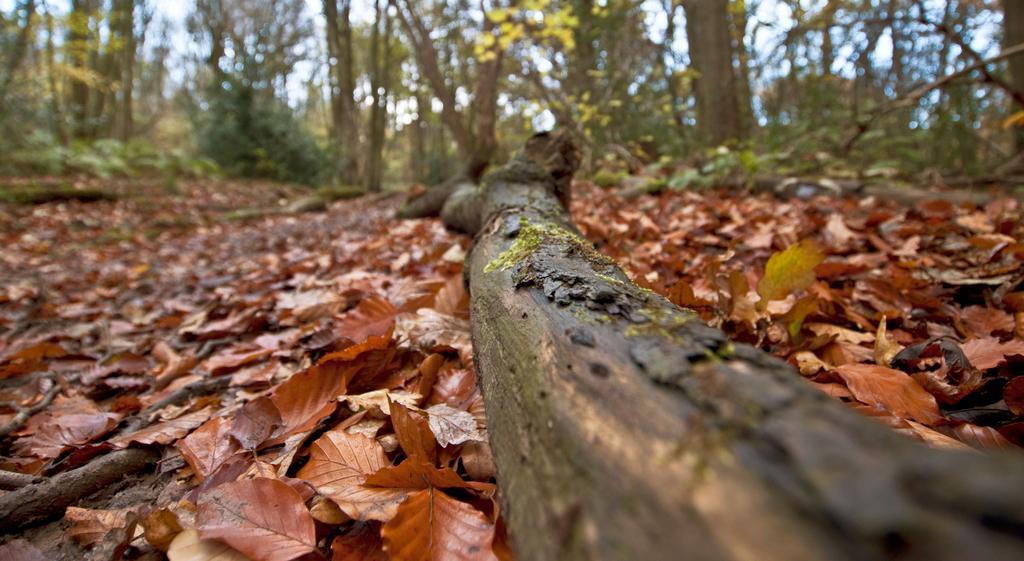Please provide a concise description of this image. In this picture we can see a wooden log, dried leaves on the ground and in the background we can see trees and the sky. 